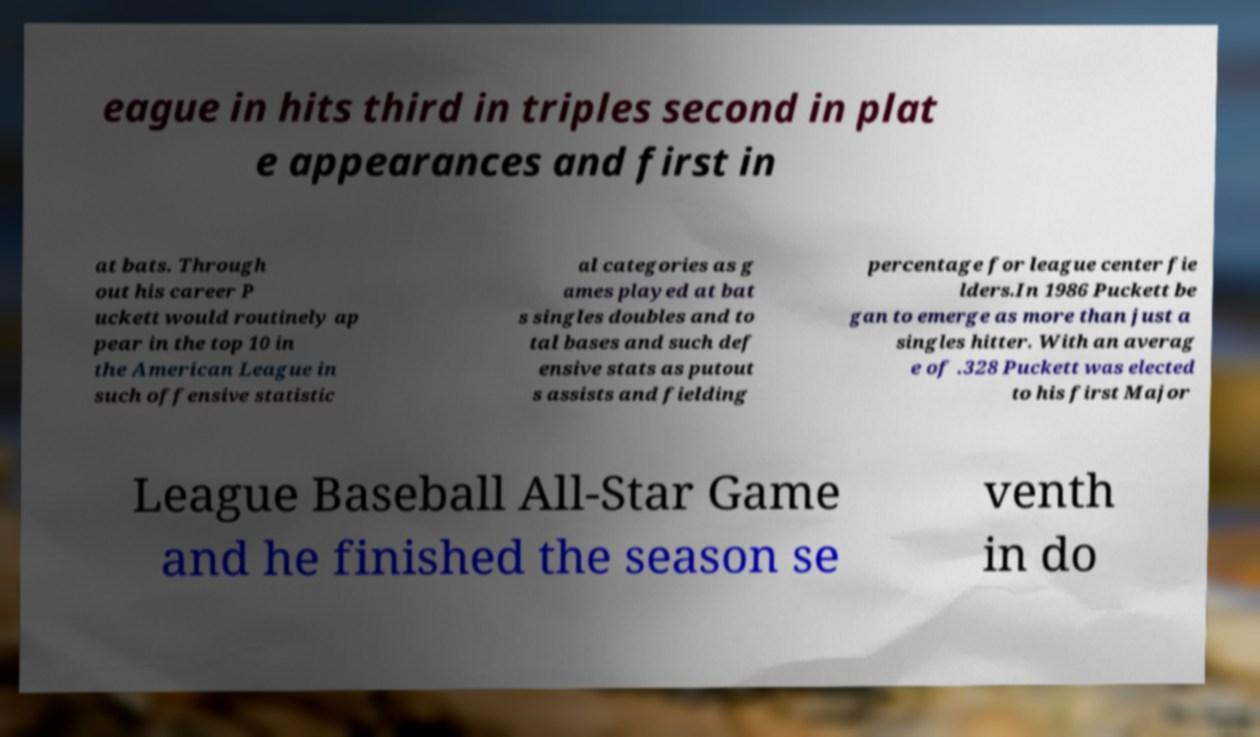Please read and relay the text visible in this image. What does it say? eague in hits third in triples second in plat e appearances and first in at bats. Through out his career P uckett would routinely ap pear in the top 10 in the American League in such offensive statistic al categories as g ames played at bat s singles doubles and to tal bases and such def ensive stats as putout s assists and fielding percentage for league center fie lders.In 1986 Puckett be gan to emerge as more than just a singles hitter. With an averag e of .328 Puckett was elected to his first Major League Baseball All-Star Game and he finished the season se venth in do 